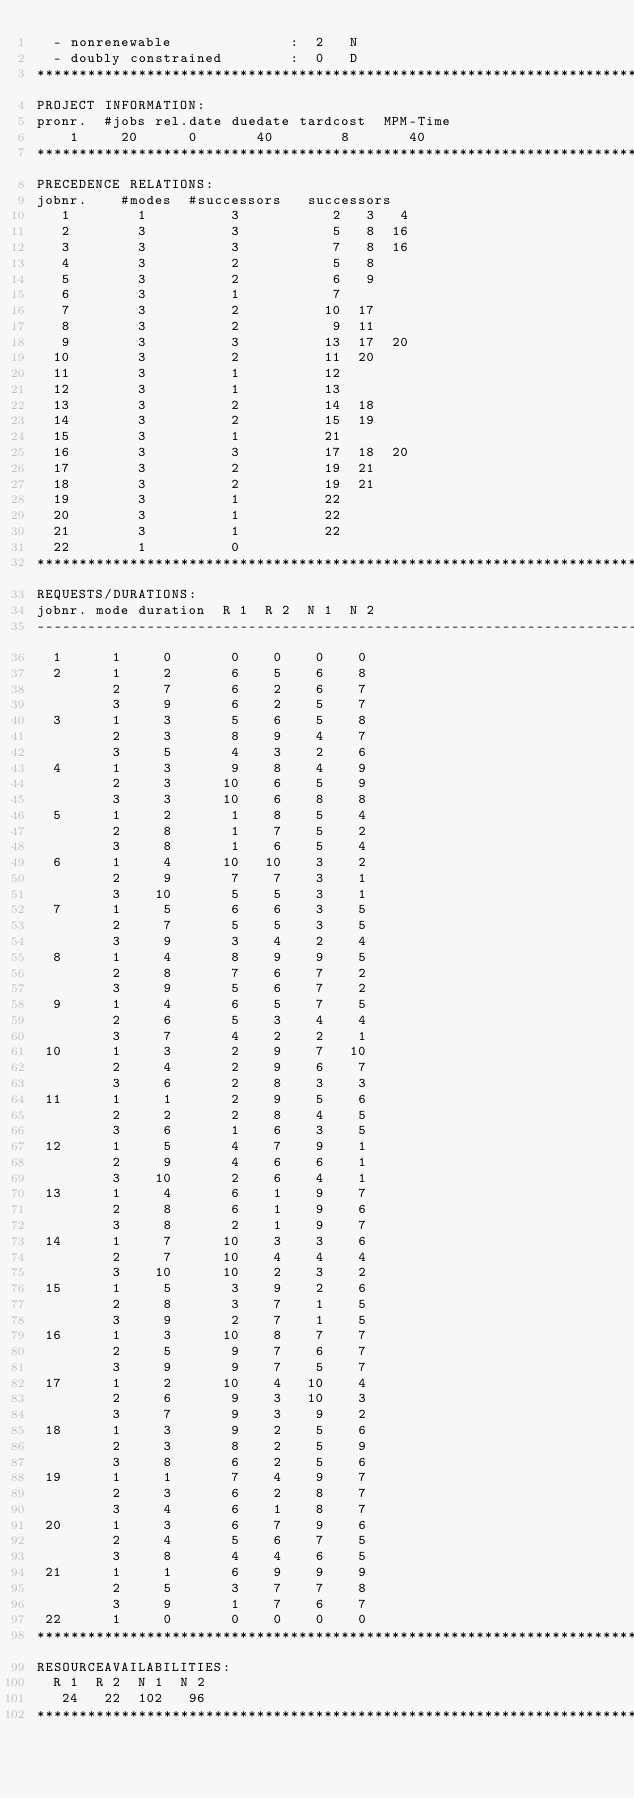Convert code to text. <code><loc_0><loc_0><loc_500><loc_500><_ObjectiveC_>  - nonrenewable              :  2   N
  - doubly constrained        :  0   D
************************************************************************
PROJECT INFORMATION:
pronr.  #jobs rel.date duedate tardcost  MPM-Time
    1     20      0       40        8       40
************************************************************************
PRECEDENCE RELATIONS:
jobnr.    #modes  #successors   successors
   1        1          3           2   3   4
   2        3          3           5   8  16
   3        3          3           7   8  16
   4        3          2           5   8
   5        3          2           6   9
   6        3          1           7
   7        3          2          10  17
   8        3          2           9  11
   9        3          3          13  17  20
  10        3          2          11  20
  11        3          1          12
  12        3          1          13
  13        3          2          14  18
  14        3          2          15  19
  15        3          1          21
  16        3          3          17  18  20
  17        3          2          19  21
  18        3          2          19  21
  19        3          1          22
  20        3          1          22
  21        3          1          22
  22        1          0        
************************************************************************
REQUESTS/DURATIONS:
jobnr. mode duration  R 1  R 2  N 1  N 2
------------------------------------------------------------------------
  1      1     0       0    0    0    0
  2      1     2       6    5    6    8
         2     7       6    2    6    7
         3     9       6    2    5    7
  3      1     3       5    6    5    8
         2     3       8    9    4    7
         3     5       4    3    2    6
  4      1     3       9    8    4    9
         2     3      10    6    5    9
         3     3      10    6    8    8
  5      1     2       1    8    5    4
         2     8       1    7    5    2
         3     8       1    6    5    4
  6      1     4      10   10    3    2
         2     9       7    7    3    1
         3    10       5    5    3    1
  7      1     5       6    6    3    5
         2     7       5    5    3    5
         3     9       3    4    2    4
  8      1     4       8    9    9    5
         2     8       7    6    7    2
         3     9       5    6    7    2
  9      1     4       6    5    7    5
         2     6       5    3    4    4
         3     7       4    2    2    1
 10      1     3       2    9    7   10
         2     4       2    9    6    7
         3     6       2    8    3    3
 11      1     1       2    9    5    6
         2     2       2    8    4    5
         3     6       1    6    3    5
 12      1     5       4    7    9    1
         2     9       4    6    6    1
         3    10       2    6    4    1
 13      1     4       6    1    9    7
         2     8       6    1    9    6
         3     8       2    1    9    7
 14      1     7      10    3    3    6
         2     7      10    4    4    4
         3    10      10    2    3    2
 15      1     5       3    9    2    6
         2     8       3    7    1    5
         3     9       2    7    1    5
 16      1     3      10    8    7    7
         2     5       9    7    6    7
         3     9       9    7    5    7
 17      1     2      10    4   10    4
         2     6       9    3   10    3
         3     7       9    3    9    2
 18      1     3       9    2    5    6
         2     3       8    2    5    9
         3     8       6    2    5    6
 19      1     1       7    4    9    7
         2     3       6    2    8    7
         3     4       6    1    8    7
 20      1     3       6    7    9    6
         2     4       5    6    7    5
         3     8       4    4    6    5
 21      1     1       6    9    9    9
         2     5       3    7    7    8
         3     9       1    7    6    7
 22      1     0       0    0    0    0
************************************************************************
RESOURCEAVAILABILITIES:
  R 1  R 2  N 1  N 2
   24   22  102   96
************************************************************************
</code> 